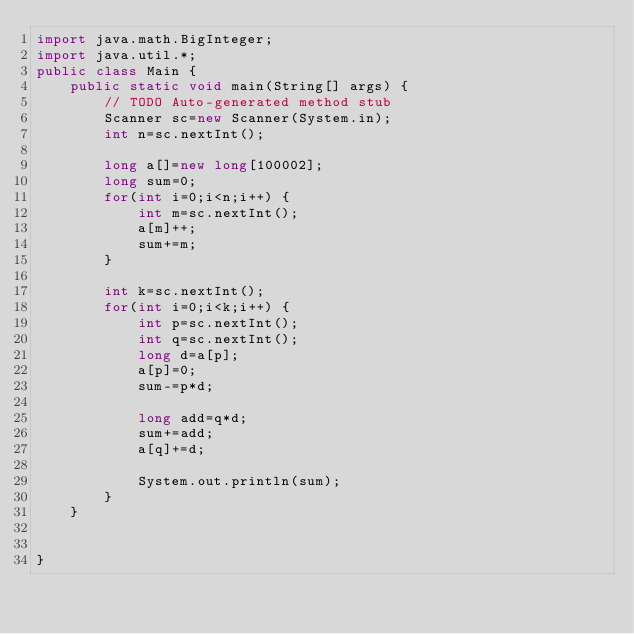<code> <loc_0><loc_0><loc_500><loc_500><_Java_>import java.math.BigInteger;
import java.util.*;
public class Main {
	public static void main(String[] args) {
		// TODO Auto-generated method stub
		Scanner sc=new Scanner(System.in);
		int n=sc.nextInt();
		
		long a[]=new long[100002];
		long sum=0;
		for(int i=0;i<n;i++) {
			int m=sc.nextInt();
			a[m]++;
			sum+=m;
		}
		
		int k=sc.nextInt();
		for(int i=0;i<k;i++) {
			int p=sc.nextInt();
			int q=sc.nextInt();
			long d=a[p];
			a[p]=0;
			sum-=p*d;
			
			long add=q*d;
			sum+=add;
			a[q]+=d;
			
			System.out.println(sum);
		}
	}
	
	
}

 
</code> 